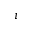<formula> <loc_0><loc_0><loc_500><loc_500>i</formula> 